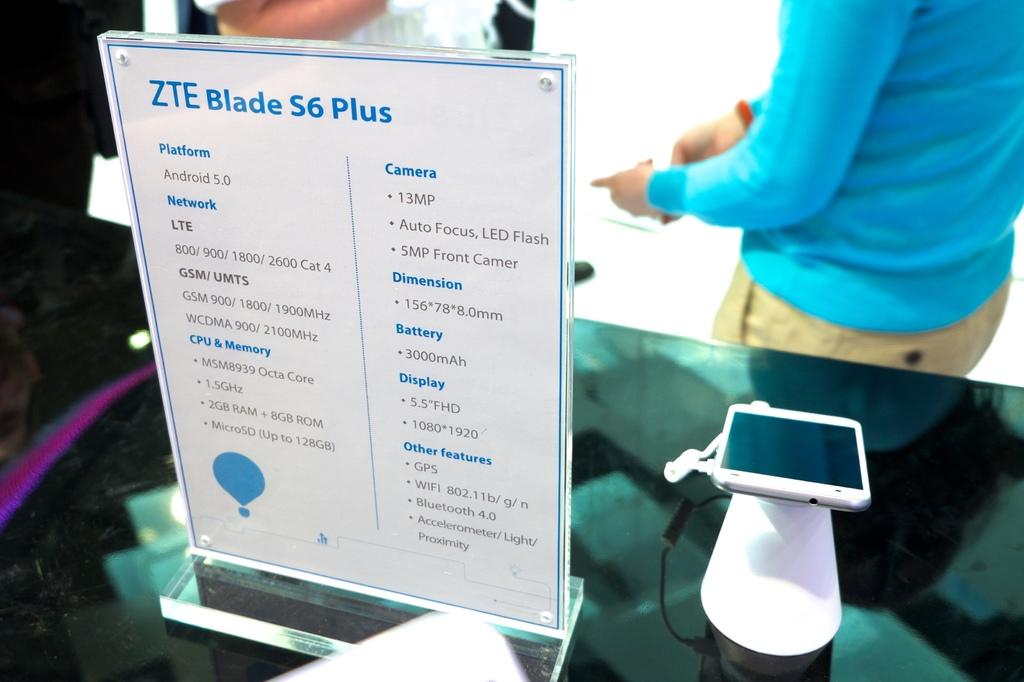What piece of furniture is visible in the image? There is a table in the image. What object can be seen on the table? A phone is present on the table. What is the other item on the table besides the phone? There is a glass board on the table. Can you describe the person in the background of the image? In the background of the image, there is a person wearing a blue color t-shirt. What season is it in the image, considering the person is wearing a summer outfit? The provided facts do not mention any information about the season or the person's outfit, so it cannot be determined from the image. 